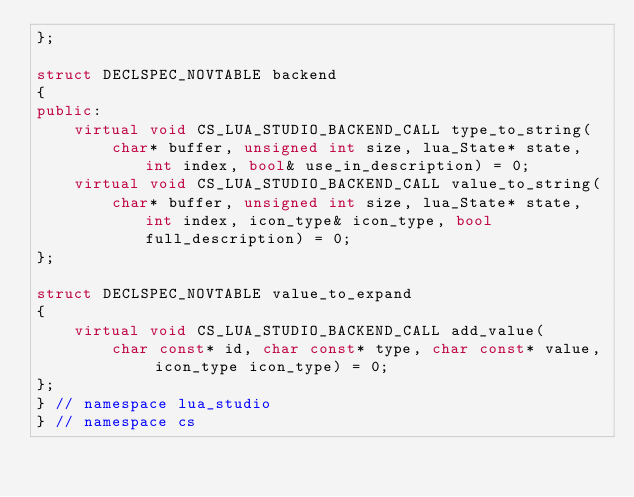Convert code to text. <code><loc_0><loc_0><loc_500><loc_500><_C++_>};

struct DECLSPEC_NOVTABLE backend
{
public:
    virtual void CS_LUA_STUDIO_BACKEND_CALL type_to_string(
        char* buffer, unsigned int size, lua_State* state, int index, bool& use_in_description) = 0;
    virtual void CS_LUA_STUDIO_BACKEND_CALL value_to_string(
        char* buffer, unsigned int size, lua_State* state, int index, icon_type& icon_type, bool full_description) = 0;
};

struct DECLSPEC_NOVTABLE value_to_expand
{
    virtual void CS_LUA_STUDIO_BACKEND_CALL add_value(
        char const* id, char const* type, char const* value, icon_type icon_type) = 0;
};
} // namespace lua_studio
} // namespace cs
</code> 